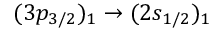Convert formula to latex. <formula><loc_0><loc_0><loc_500><loc_500>( 3 p _ { 3 / 2 } ) _ { 1 } \rightarrow ( 2 s _ { 1 / 2 } ) _ { 1 }</formula> 